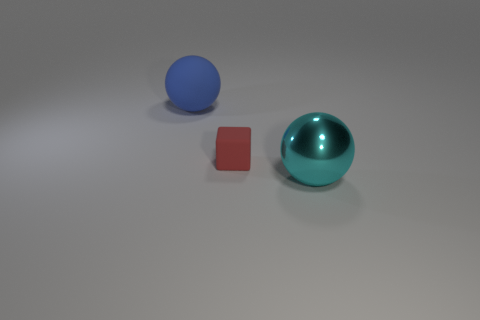Add 2 big balls. How many objects exist? 5 Subtract 1 cubes. How many cubes are left? 0 Subtract all cubes. How many objects are left? 2 Add 2 big green cylinders. How many big green cylinders exist? 2 Subtract 0 brown cylinders. How many objects are left? 3 Subtract all gray blocks. Subtract all yellow balls. How many blocks are left? 1 Subtract all large gray cylinders. Subtract all small matte objects. How many objects are left? 2 Add 3 red cubes. How many red cubes are left? 4 